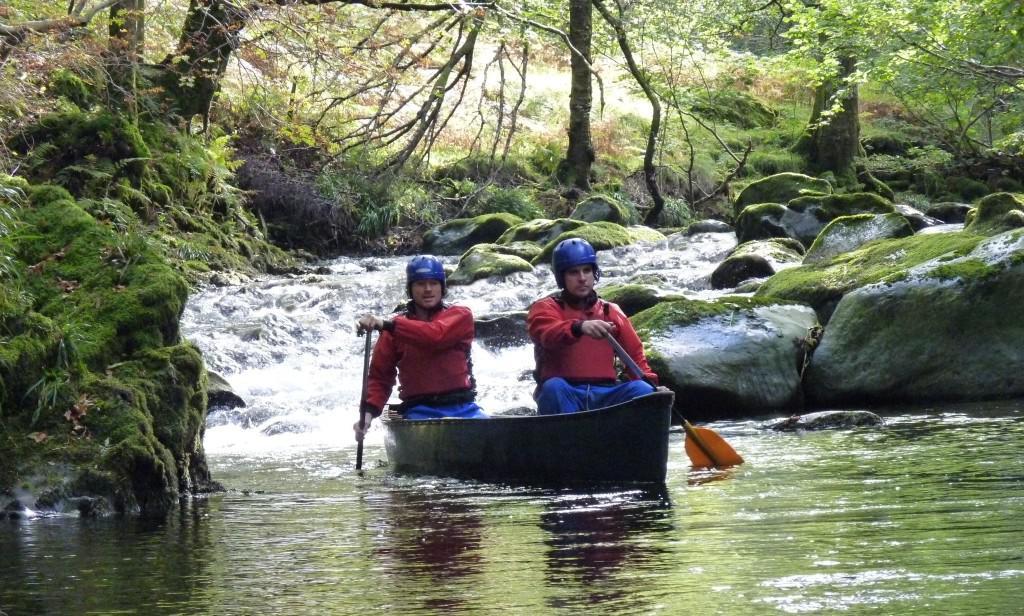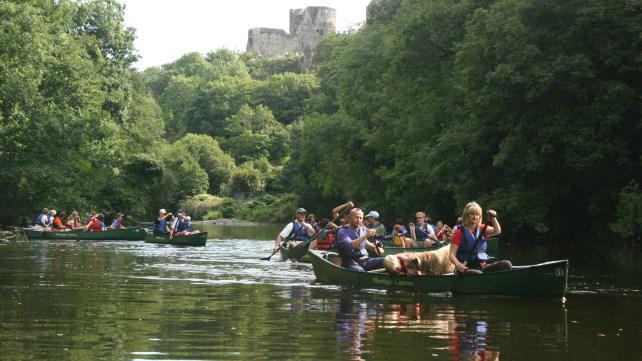The first image is the image on the left, the second image is the image on the right. Examine the images to the left and right. Is the description "The right image features multiple canoes heading forward at a right angle that are not aligned side-by-side." accurate? Answer yes or no. Yes. The first image is the image on the left, the second image is the image on the right. For the images displayed, is the sentence "There is more than one canoe in each image." factually correct? Answer yes or no. No. 